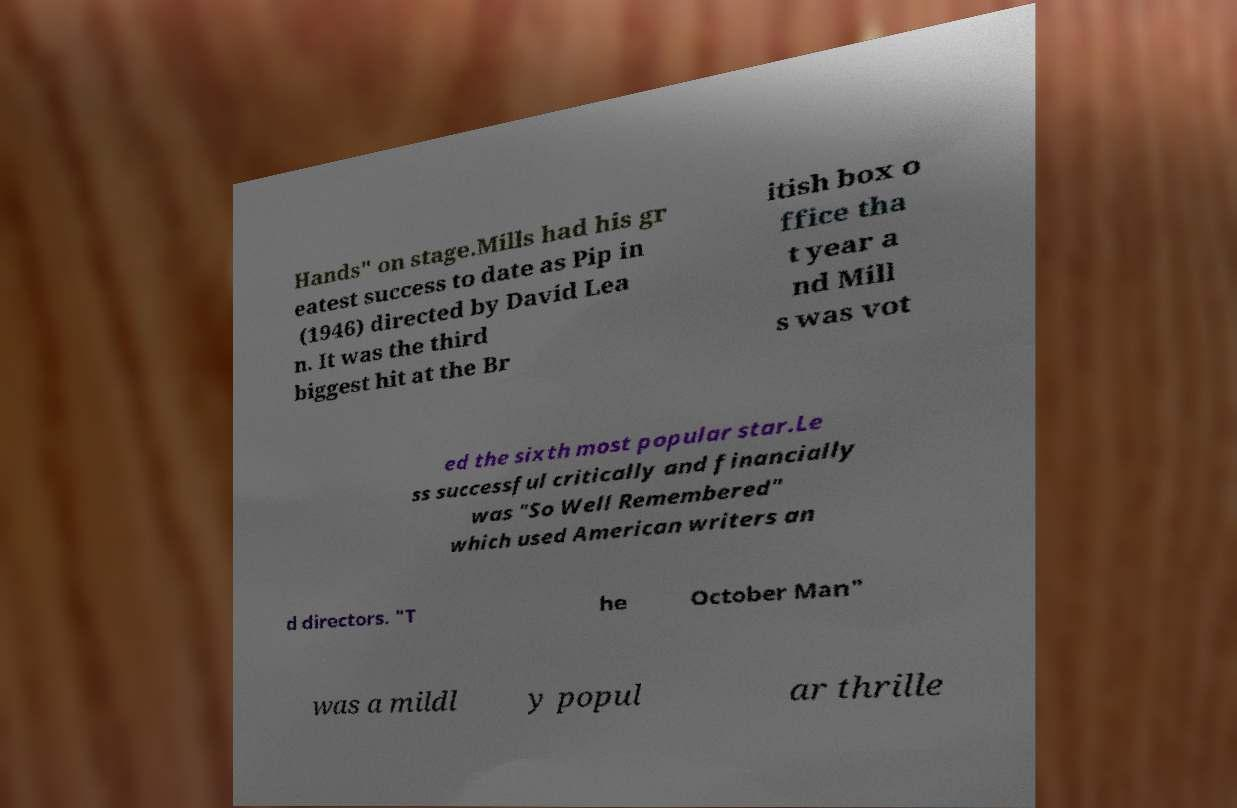Could you assist in decoding the text presented in this image and type it out clearly? Hands" on stage.Mills had his gr eatest success to date as Pip in (1946) directed by David Lea n. It was the third biggest hit at the Br itish box o ffice tha t year a nd Mill s was vot ed the sixth most popular star.Le ss successful critically and financially was "So Well Remembered" which used American writers an d directors. "T he October Man" was a mildl y popul ar thrille 